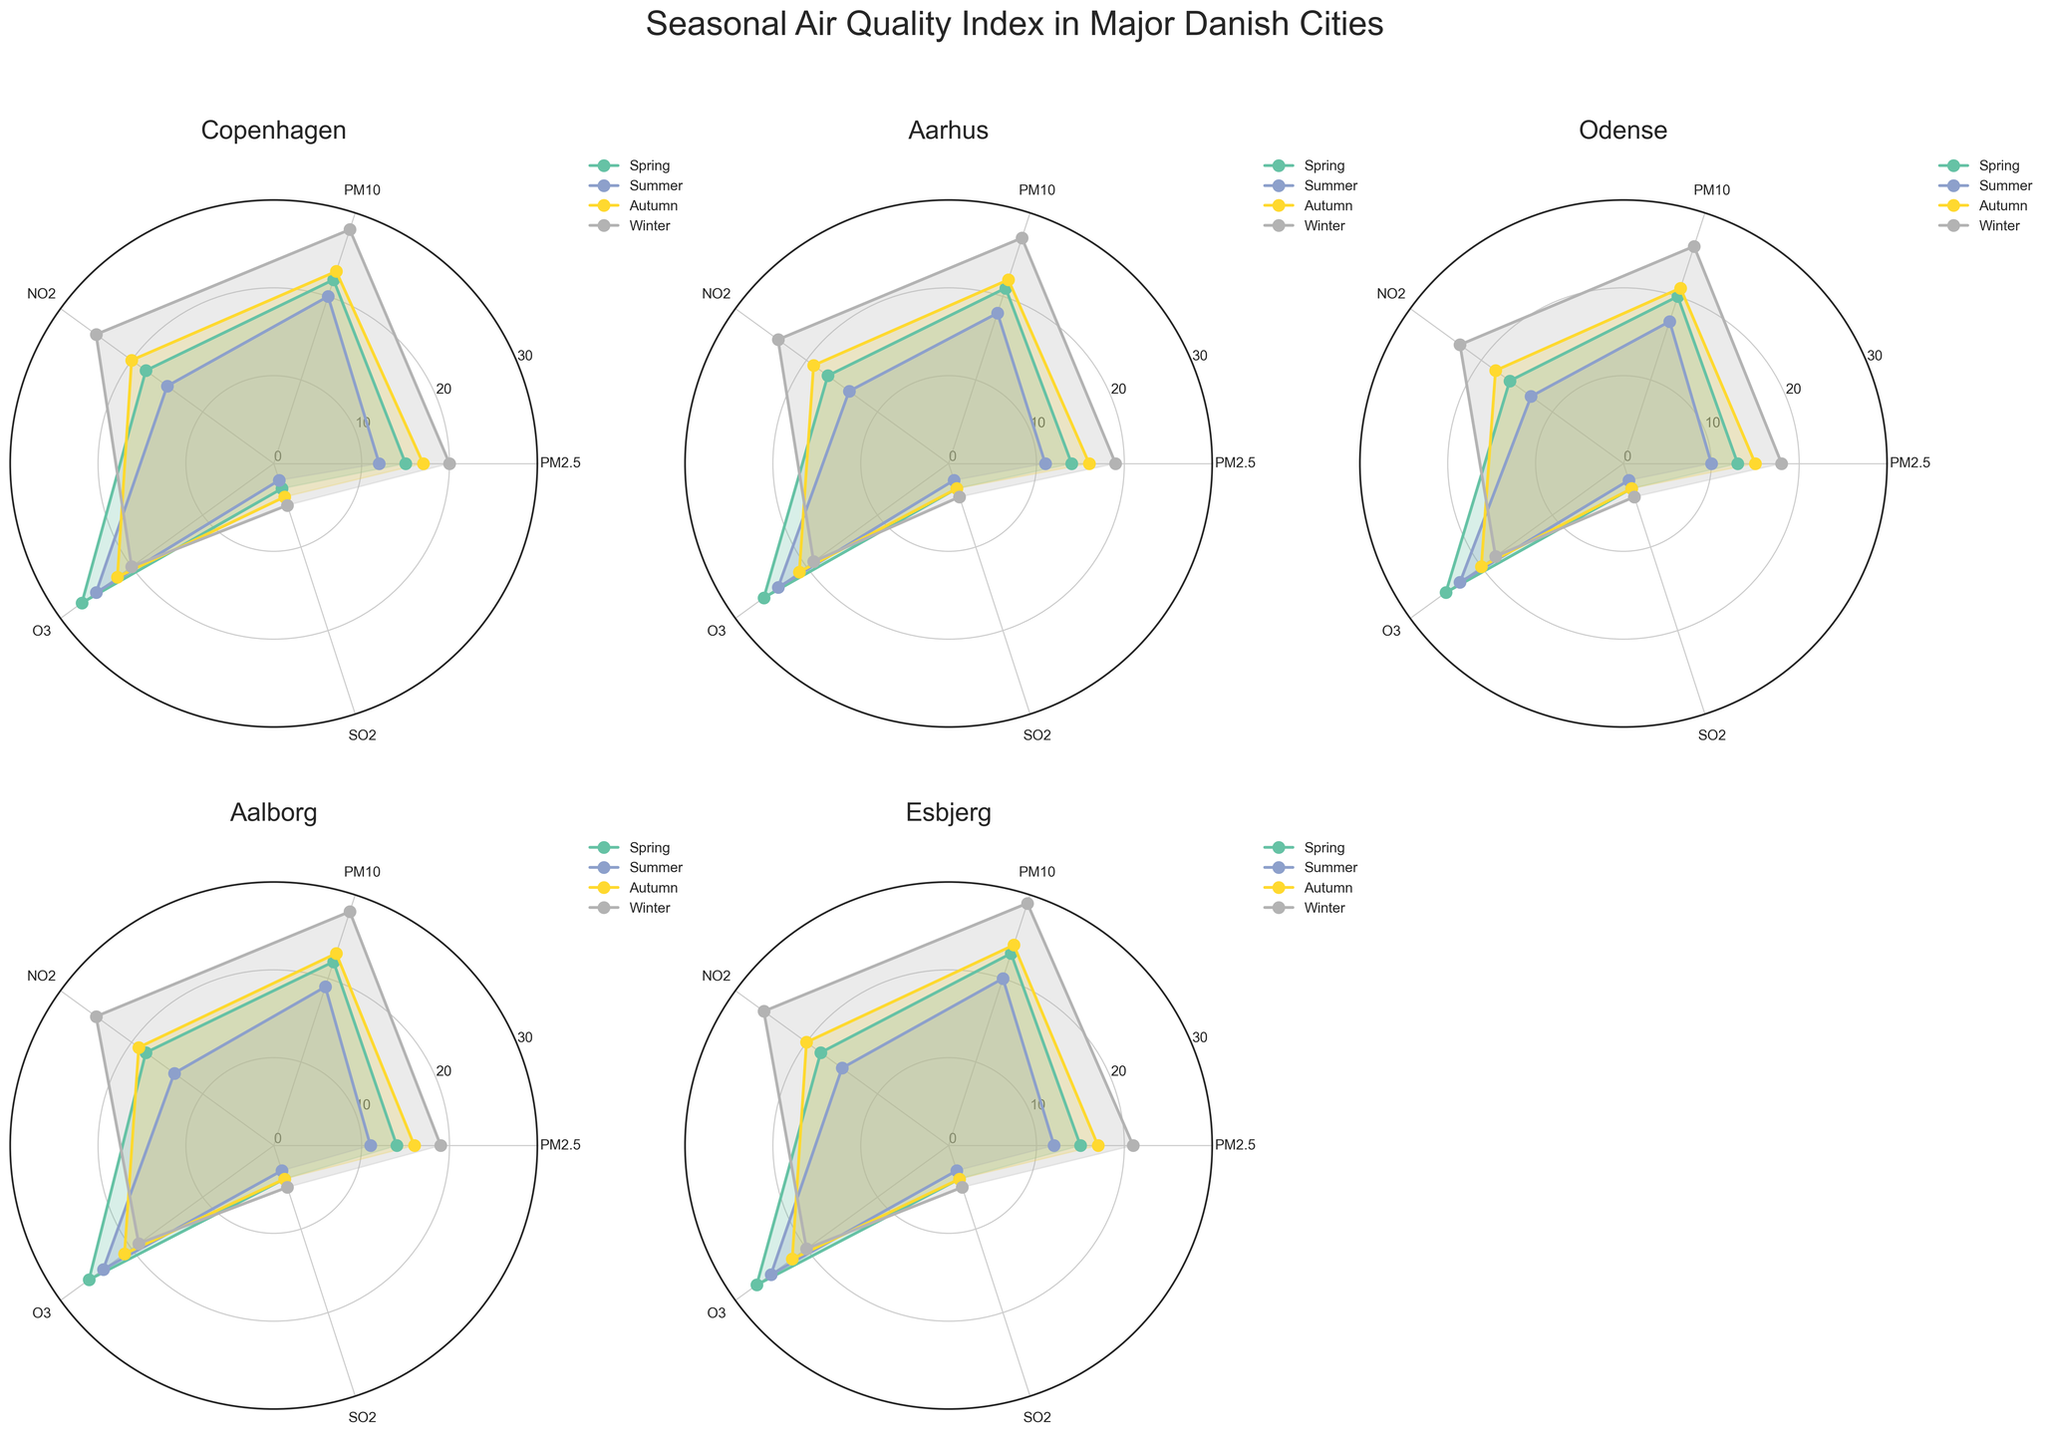What is the title of the figure? The title of the figure is located at the top of the plot and is typically written in a larger font size for easier visibility.
Answer: Seasonal Air Quality Index in Major Danish Cities Which city shows the highest air pollution in winter for PM10? By examining the plots for each city, look for the highest radial extent of the PM10 data point in the winter season (indicated by the corresponding legend color for winter).
Answer: Esbjerg How does the average PM2.5 level in summer compare between Copenhagen and Aarhus? Calculate the average PM2.5 level for summer in both Copenhagen (12) and Aarhus (11), then compare the two values.
Answer: Copenhagen has a slightly higher PM2.5 level in summer than Aarhus Which city has the highest SO2 levels in autumn? Look at the data points for SO2 in the autumn season across all the cities. The highest point corresponds to the city with the highest SO2 level.
Answer: Aalborg and Esbjerg both have the highest SO2 levels in autumn What season does Odense experience the cleanest air based on the overall pollutants? Evaluate the radial extent for each pollutant across all the seasons for Odense and determine which season shows the lowest overall values.
Answer: Summer In which city and season does PM2.5 show the minimum value? Search for the lowest value of PM2.5 across all cities and seasons.
Answer: Odense in Summer Compare the average SO2 levels in spring between Copenhagen and Esbjerg. Calculate the average SO2 level in spring for Copenhagen (3) and Esbjerg (4), then compare these values.
Answer: Esbjerg has higher SO2 levels in spring than Copenhagen Which pollutant shows the least variation in levels between seasons in Aarhus? Examine the radial values for each pollutant in Aarhus across all seasons and identify the pollutant with the smallest range.
Answer: SO2 How do the NO2 levels in winter compare between Odense and Aalborg? Compare the radial values for NO2 in winter for Odense (23) and Aalborg (25).
Answer: Aalborg has higher NO2 levels in winter than Odense Which season shows the highest average PM10 level across all cities? Calculate the average PM10 levels for each season across all cities and identify the season with the highest average.
Answer: Winter 